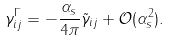Convert formula to latex. <formula><loc_0><loc_0><loc_500><loc_500>\gamma ^ { \Gamma } _ { i j } = - \frac { \alpha _ { s } } { 4 \pi } \tilde { \gamma } _ { i j } + \mathcal { O } ( \alpha _ { s } ^ { 2 } ) .</formula> 